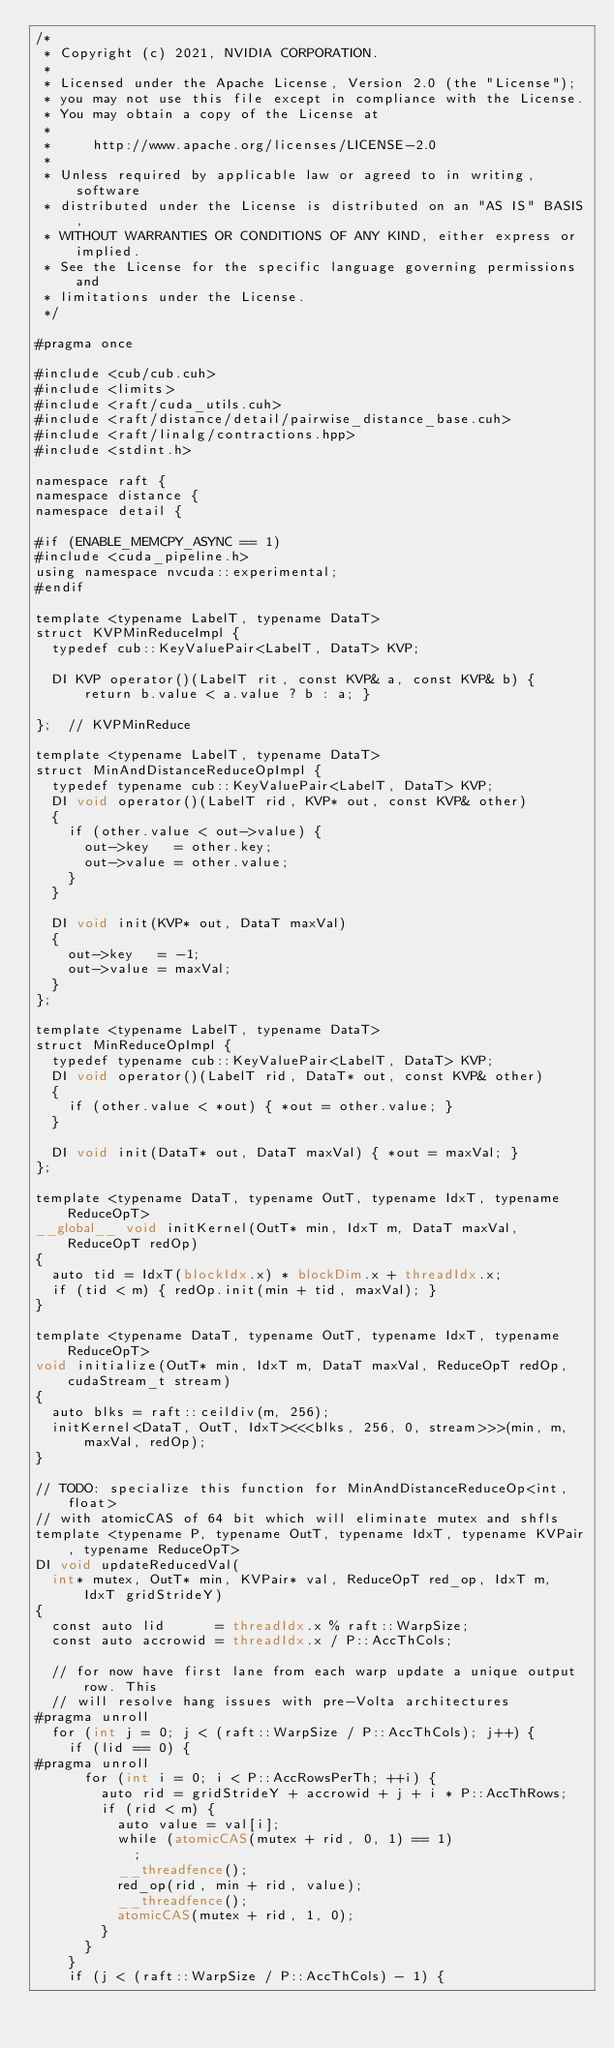Convert code to text. <code><loc_0><loc_0><loc_500><loc_500><_Cuda_>/*
 * Copyright (c) 2021, NVIDIA CORPORATION.
 *
 * Licensed under the Apache License, Version 2.0 (the "License");
 * you may not use this file except in compliance with the License.
 * You may obtain a copy of the License at
 *
 *     http://www.apache.org/licenses/LICENSE-2.0
 *
 * Unless required by applicable law or agreed to in writing, software
 * distributed under the License is distributed on an "AS IS" BASIS,
 * WITHOUT WARRANTIES OR CONDITIONS OF ANY KIND, either express or implied.
 * See the License for the specific language governing permissions and
 * limitations under the License.
 */

#pragma once

#include <cub/cub.cuh>
#include <limits>
#include <raft/cuda_utils.cuh>
#include <raft/distance/detail/pairwise_distance_base.cuh>
#include <raft/linalg/contractions.hpp>
#include <stdint.h>

namespace raft {
namespace distance {
namespace detail {

#if (ENABLE_MEMCPY_ASYNC == 1)
#include <cuda_pipeline.h>
using namespace nvcuda::experimental;
#endif

template <typename LabelT, typename DataT>
struct KVPMinReduceImpl {
  typedef cub::KeyValuePair<LabelT, DataT> KVP;

  DI KVP operator()(LabelT rit, const KVP& a, const KVP& b) { return b.value < a.value ? b : a; }

};  // KVPMinReduce

template <typename LabelT, typename DataT>
struct MinAndDistanceReduceOpImpl {
  typedef typename cub::KeyValuePair<LabelT, DataT> KVP;
  DI void operator()(LabelT rid, KVP* out, const KVP& other)
  {
    if (other.value < out->value) {
      out->key   = other.key;
      out->value = other.value;
    }
  }

  DI void init(KVP* out, DataT maxVal)
  {
    out->key   = -1;
    out->value = maxVal;
  }
};

template <typename LabelT, typename DataT>
struct MinReduceOpImpl {
  typedef typename cub::KeyValuePair<LabelT, DataT> KVP;
  DI void operator()(LabelT rid, DataT* out, const KVP& other)
  {
    if (other.value < *out) { *out = other.value; }
  }

  DI void init(DataT* out, DataT maxVal) { *out = maxVal; }
};

template <typename DataT, typename OutT, typename IdxT, typename ReduceOpT>
__global__ void initKernel(OutT* min, IdxT m, DataT maxVal, ReduceOpT redOp)
{
  auto tid = IdxT(blockIdx.x) * blockDim.x + threadIdx.x;
  if (tid < m) { redOp.init(min + tid, maxVal); }
}

template <typename DataT, typename OutT, typename IdxT, typename ReduceOpT>
void initialize(OutT* min, IdxT m, DataT maxVal, ReduceOpT redOp, cudaStream_t stream)
{
  auto blks = raft::ceildiv(m, 256);
  initKernel<DataT, OutT, IdxT><<<blks, 256, 0, stream>>>(min, m, maxVal, redOp);
}

// TODO: specialize this function for MinAndDistanceReduceOp<int, float>
// with atomicCAS of 64 bit which will eliminate mutex and shfls
template <typename P, typename OutT, typename IdxT, typename KVPair, typename ReduceOpT>
DI void updateReducedVal(
  int* mutex, OutT* min, KVPair* val, ReduceOpT red_op, IdxT m, IdxT gridStrideY)
{
  const auto lid      = threadIdx.x % raft::WarpSize;
  const auto accrowid = threadIdx.x / P::AccThCols;

  // for now have first lane from each warp update a unique output row. This
  // will resolve hang issues with pre-Volta architectures
#pragma unroll
  for (int j = 0; j < (raft::WarpSize / P::AccThCols); j++) {
    if (lid == 0) {
#pragma unroll
      for (int i = 0; i < P::AccRowsPerTh; ++i) {
        auto rid = gridStrideY + accrowid + j + i * P::AccThRows;
        if (rid < m) {
          auto value = val[i];
          while (atomicCAS(mutex + rid, 0, 1) == 1)
            ;
          __threadfence();
          red_op(rid, min + rid, value);
          __threadfence();
          atomicCAS(mutex + rid, 1, 0);
        }
      }
    }
    if (j < (raft::WarpSize / P::AccThCols) - 1) {</code> 